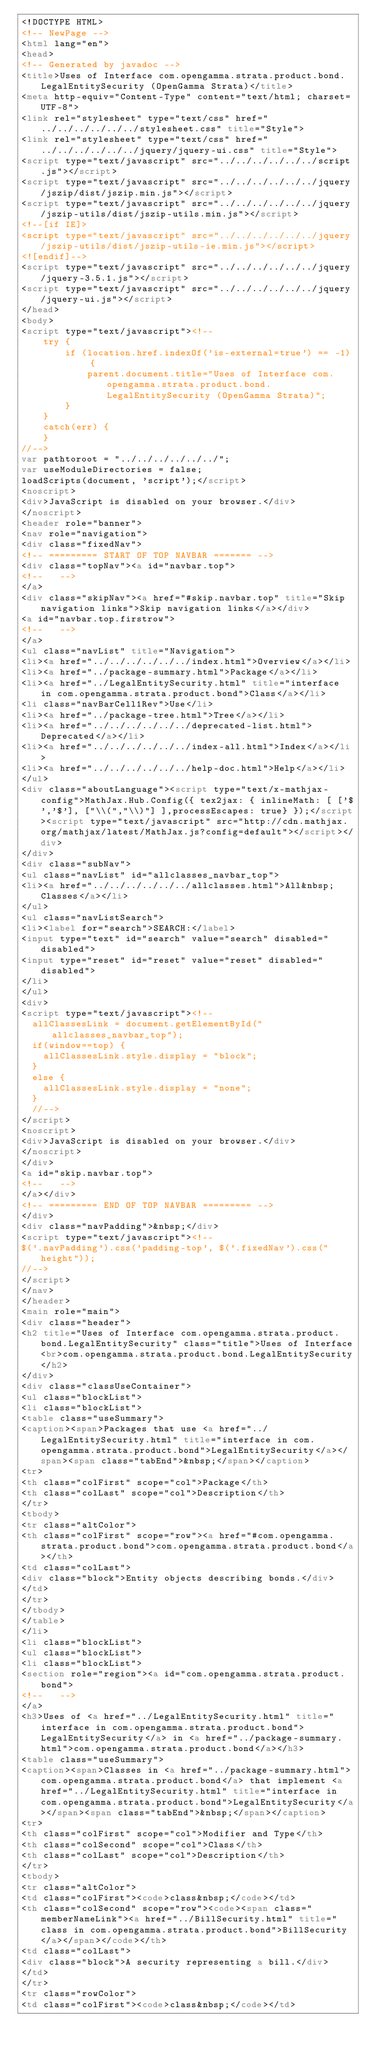Convert code to text. <code><loc_0><loc_0><loc_500><loc_500><_HTML_><!DOCTYPE HTML>
<!-- NewPage -->
<html lang="en">
<head>
<!-- Generated by javadoc -->
<title>Uses of Interface com.opengamma.strata.product.bond.LegalEntitySecurity (OpenGamma Strata)</title>
<meta http-equiv="Content-Type" content="text/html; charset=UTF-8">
<link rel="stylesheet" type="text/css" href="../../../../../../stylesheet.css" title="Style">
<link rel="stylesheet" type="text/css" href="../../../../../../jquery/jquery-ui.css" title="Style">
<script type="text/javascript" src="../../../../../../script.js"></script>
<script type="text/javascript" src="../../../../../../jquery/jszip/dist/jszip.min.js"></script>
<script type="text/javascript" src="../../../../../../jquery/jszip-utils/dist/jszip-utils.min.js"></script>
<!--[if IE]>
<script type="text/javascript" src="../../../../../../jquery/jszip-utils/dist/jszip-utils-ie.min.js"></script>
<![endif]-->
<script type="text/javascript" src="../../../../../../jquery/jquery-3.5.1.js"></script>
<script type="text/javascript" src="../../../../../../jquery/jquery-ui.js"></script>
</head>
<body>
<script type="text/javascript"><!--
    try {
        if (location.href.indexOf('is-external=true') == -1) {
            parent.document.title="Uses of Interface com.opengamma.strata.product.bond.LegalEntitySecurity (OpenGamma Strata)";
        }
    }
    catch(err) {
    }
//-->
var pathtoroot = "../../../../../../";
var useModuleDirectories = false;
loadScripts(document, 'script');</script>
<noscript>
<div>JavaScript is disabled on your browser.</div>
</noscript>
<header role="banner">
<nav role="navigation">
<div class="fixedNav">
<!-- ========= START OF TOP NAVBAR ======= -->
<div class="topNav"><a id="navbar.top">
<!--   -->
</a>
<div class="skipNav"><a href="#skip.navbar.top" title="Skip navigation links">Skip navigation links</a></div>
<a id="navbar.top.firstrow">
<!--   -->
</a>
<ul class="navList" title="Navigation">
<li><a href="../../../../../../index.html">Overview</a></li>
<li><a href="../package-summary.html">Package</a></li>
<li><a href="../LegalEntitySecurity.html" title="interface in com.opengamma.strata.product.bond">Class</a></li>
<li class="navBarCell1Rev">Use</li>
<li><a href="../package-tree.html">Tree</a></li>
<li><a href="../../../../../../deprecated-list.html">Deprecated</a></li>
<li><a href="../../../../../../index-all.html">Index</a></li>
<li><a href="../../../../../../help-doc.html">Help</a></li>
</ul>
<div class="aboutLanguage"><script type="text/x-mathjax-config">MathJax.Hub.Config({ tex2jax: { inlineMath: [ ['$','$'], ["\\(","\\)"] ],processEscapes: true} });</script><script type="text/javascript" src="http://cdn.mathjax.org/mathjax/latest/MathJax.js?config=default"></script></div>
</div>
<div class="subNav">
<ul class="navList" id="allclasses_navbar_top">
<li><a href="../../../../../../allclasses.html">All&nbsp;Classes</a></li>
</ul>
<ul class="navListSearch">
<li><label for="search">SEARCH:</label>
<input type="text" id="search" value="search" disabled="disabled">
<input type="reset" id="reset" value="reset" disabled="disabled">
</li>
</ul>
<div>
<script type="text/javascript"><!--
  allClassesLink = document.getElementById("allclasses_navbar_top");
  if(window==top) {
    allClassesLink.style.display = "block";
  }
  else {
    allClassesLink.style.display = "none";
  }
  //-->
</script>
<noscript>
<div>JavaScript is disabled on your browser.</div>
</noscript>
</div>
<a id="skip.navbar.top">
<!--   -->
</a></div>
<!-- ========= END OF TOP NAVBAR ========= -->
</div>
<div class="navPadding">&nbsp;</div>
<script type="text/javascript"><!--
$('.navPadding').css('padding-top', $('.fixedNav').css("height"));
//-->
</script>
</nav>
</header>
<main role="main">
<div class="header">
<h2 title="Uses of Interface com.opengamma.strata.product.bond.LegalEntitySecurity" class="title">Uses of Interface<br>com.opengamma.strata.product.bond.LegalEntitySecurity</h2>
</div>
<div class="classUseContainer">
<ul class="blockList">
<li class="blockList">
<table class="useSummary">
<caption><span>Packages that use <a href="../LegalEntitySecurity.html" title="interface in com.opengamma.strata.product.bond">LegalEntitySecurity</a></span><span class="tabEnd">&nbsp;</span></caption>
<tr>
<th class="colFirst" scope="col">Package</th>
<th class="colLast" scope="col">Description</th>
</tr>
<tbody>
<tr class="altColor">
<th class="colFirst" scope="row"><a href="#com.opengamma.strata.product.bond">com.opengamma.strata.product.bond</a></th>
<td class="colLast">
<div class="block">Entity objects describing bonds.</div>
</td>
</tr>
</tbody>
</table>
</li>
<li class="blockList">
<ul class="blockList">
<li class="blockList">
<section role="region"><a id="com.opengamma.strata.product.bond">
<!--   -->
</a>
<h3>Uses of <a href="../LegalEntitySecurity.html" title="interface in com.opengamma.strata.product.bond">LegalEntitySecurity</a> in <a href="../package-summary.html">com.opengamma.strata.product.bond</a></h3>
<table class="useSummary">
<caption><span>Classes in <a href="../package-summary.html">com.opengamma.strata.product.bond</a> that implement <a href="../LegalEntitySecurity.html" title="interface in com.opengamma.strata.product.bond">LegalEntitySecurity</a></span><span class="tabEnd">&nbsp;</span></caption>
<tr>
<th class="colFirst" scope="col">Modifier and Type</th>
<th class="colSecond" scope="col">Class</th>
<th class="colLast" scope="col">Description</th>
</tr>
<tbody>
<tr class="altColor">
<td class="colFirst"><code>class&nbsp;</code></td>
<th class="colSecond" scope="row"><code><span class="memberNameLink"><a href="../BillSecurity.html" title="class in com.opengamma.strata.product.bond">BillSecurity</a></span></code></th>
<td class="colLast">
<div class="block">A security representing a bill.</div>
</td>
</tr>
<tr class="rowColor">
<td class="colFirst"><code>class&nbsp;</code></td></code> 